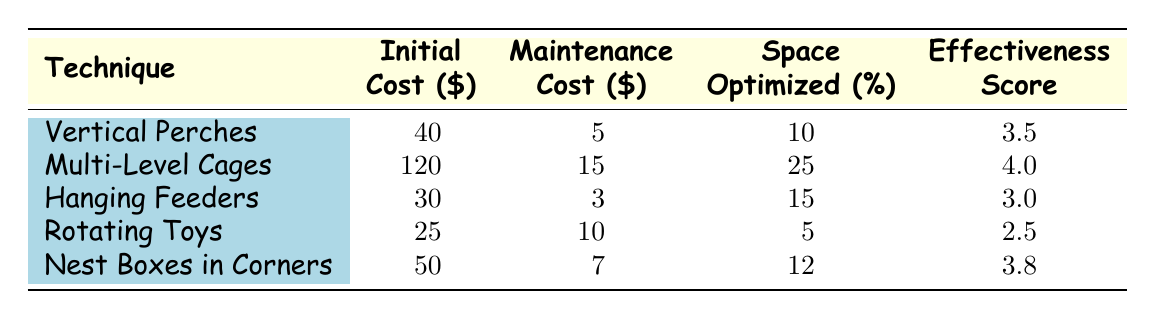What is the initial cost of Multi-Level Cages? The table lists the initial cost for Multi-Level Cages as 120.
Answer: 120 Which space optimization technique has the highest effectiveness score? Comparing the effectiveness scores in the table, Multi-Level Cages has the highest score of 4.0.
Answer: Multi-Level Cages What is the total maintenance cost for Vertical Perches and Nest Boxes in Corners? The maintenance cost for Vertical Perches is 5 and for Nest Boxes in Corners is 7. Adding these gives 5 + 7 = 12.
Answer: 12 Are hanging feeders more cost-effective than rotating toys based on their effectiveness scores? Hanging Feeders have an effectiveness score of 3.0, while Rotating Toys have a score of 2.5, which means hanging feeders are more effective.
Answer: Yes What is the average space optimized across all techniques? The space optimized values are 10, 25, 15, 5, and 12. The total is 10 + 25 + 15 + 5 + 12 = 67, and there are 5 techniques, so the average is 67/5 = 13.4.
Answer: 13.4 Which technique has the lowest initial cost? Comparing the initial costs listed in the table, Rotating Toys has the lowest cost of 25.
Answer: Rotating Toys What is the difference in space optimized between Multi-Level Cages and Vertical Perches? Multi-Level Cages optimize 25 and Vertical Perches optimize 10. The difference is 25 - 10 = 15.
Answer: 15 Do Nest Boxes in Corners require a higher maintenance cost than Vertical Perches? Nest Boxes in Corners require a maintenance cost of 7, while Vertical Perches need 5, indicating that nest boxes have a higher maintenance cost.
Answer: Yes 